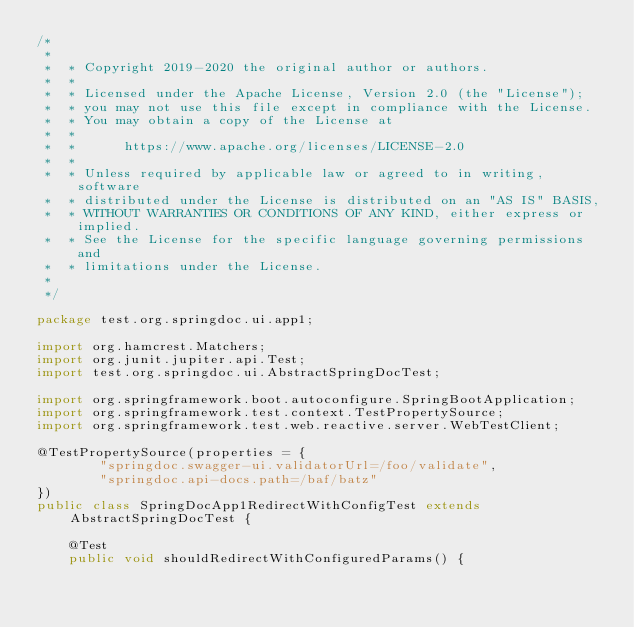<code> <loc_0><loc_0><loc_500><loc_500><_Java_>/*
 *
 *  * Copyright 2019-2020 the original author or authors.
 *  *
 *  * Licensed under the Apache License, Version 2.0 (the "License");
 *  * you may not use this file except in compliance with the License.
 *  * You may obtain a copy of the License at
 *  *
 *  *      https://www.apache.org/licenses/LICENSE-2.0
 *  *
 *  * Unless required by applicable law or agreed to in writing, software
 *  * distributed under the License is distributed on an "AS IS" BASIS,
 *  * WITHOUT WARRANTIES OR CONDITIONS OF ANY KIND, either express or implied.
 *  * See the License for the specific language governing permissions and
 *  * limitations under the License.
 *
 */

package test.org.springdoc.ui.app1;

import org.hamcrest.Matchers;
import org.junit.jupiter.api.Test;
import test.org.springdoc.ui.AbstractSpringDocTest;

import org.springframework.boot.autoconfigure.SpringBootApplication;
import org.springframework.test.context.TestPropertySource;
import org.springframework.test.web.reactive.server.WebTestClient;

@TestPropertySource(properties = {
		"springdoc.swagger-ui.validatorUrl=/foo/validate",
		"springdoc.api-docs.path=/baf/batz"
})
public class SpringDocApp1RedirectWithConfigTest extends AbstractSpringDocTest {

	@Test
	public void shouldRedirectWithConfiguredParams() {</code> 